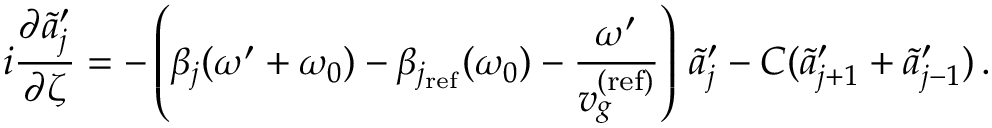Convert formula to latex. <formula><loc_0><loc_0><loc_500><loc_500>i \frac { \partial \tilde { a } _ { j } ^ { \prime } } { \partial \zeta } = - \left ( \beta _ { j } ( \omega ^ { \prime } + \omega _ { 0 } ) - \beta _ { j _ { r e f } } ( \omega _ { 0 } ) - \frac { \omega ^ { \prime } } { v _ { g } ^ { ( r e f ) } } \right ) \, \tilde { a } _ { j } ^ { \prime } - C ( \tilde { a } _ { j + 1 } ^ { \prime } + \tilde { a } _ { j - 1 } ^ { \prime } ) \, .</formula> 